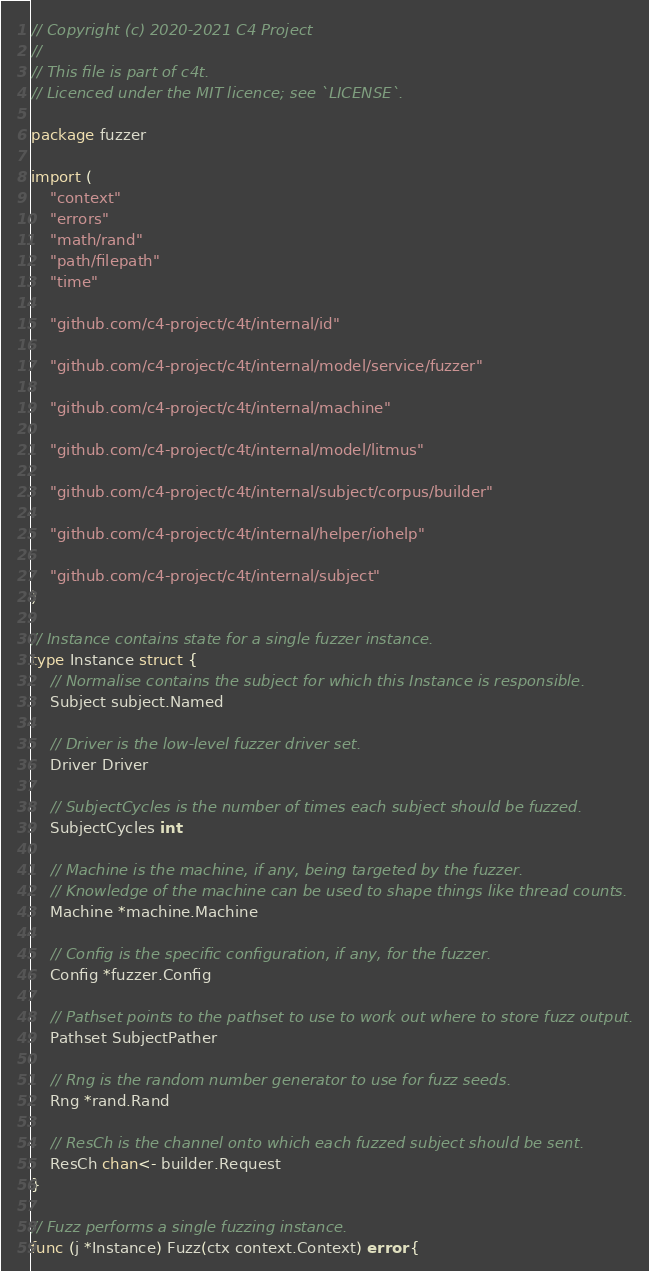Convert code to text. <code><loc_0><loc_0><loc_500><loc_500><_Go_>// Copyright (c) 2020-2021 C4 Project
//
// This file is part of c4t.
// Licenced under the MIT licence; see `LICENSE`.

package fuzzer

import (
	"context"
	"errors"
	"math/rand"
	"path/filepath"
	"time"

	"github.com/c4-project/c4t/internal/id"

	"github.com/c4-project/c4t/internal/model/service/fuzzer"

	"github.com/c4-project/c4t/internal/machine"

	"github.com/c4-project/c4t/internal/model/litmus"

	"github.com/c4-project/c4t/internal/subject/corpus/builder"

	"github.com/c4-project/c4t/internal/helper/iohelp"

	"github.com/c4-project/c4t/internal/subject"
)

// Instance contains state for a single fuzzer instance.
type Instance struct {
	// Normalise contains the subject for which this Instance is responsible.
	Subject subject.Named

	// Driver is the low-level fuzzer driver set.
	Driver Driver

	// SubjectCycles is the number of times each subject should be fuzzed.
	SubjectCycles int

	// Machine is the machine, if any, being targeted by the fuzzer.
	// Knowledge of the machine can be used to shape things like thread counts.
	Machine *machine.Machine

	// Config is the specific configuration, if any, for the fuzzer.
	Config *fuzzer.Config

	// Pathset points to the pathset to use to work out where to store fuzz output.
	Pathset SubjectPather

	// Rng is the random number generator to use for fuzz seeds.
	Rng *rand.Rand

	// ResCh is the channel onto which each fuzzed subject should be sent.
	ResCh chan<- builder.Request
}

// Fuzz performs a single fuzzing instance.
func (j *Instance) Fuzz(ctx context.Context) error {</code> 